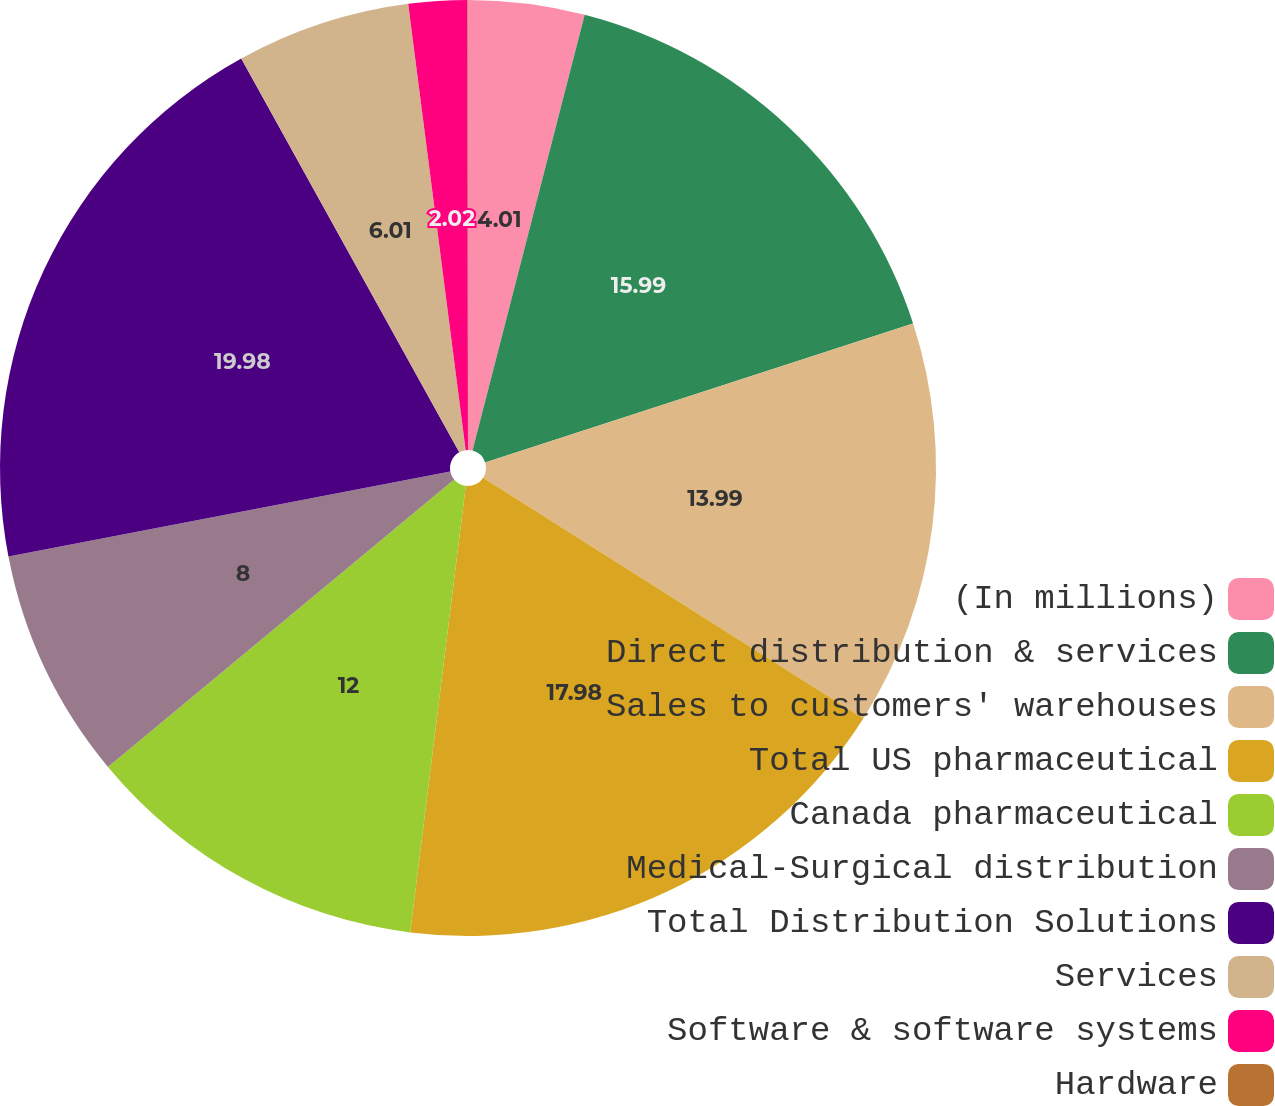<chart> <loc_0><loc_0><loc_500><loc_500><pie_chart><fcel>(In millions)<fcel>Direct distribution & services<fcel>Sales to customers' warehouses<fcel>Total US pharmaceutical<fcel>Canada pharmaceutical<fcel>Medical-Surgical distribution<fcel>Total Distribution Solutions<fcel>Services<fcel>Software & software systems<fcel>Hardware<nl><fcel>4.01%<fcel>15.99%<fcel>13.99%<fcel>17.98%<fcel>12.0%<fcel>8.0%<fcel>19.98%<fcel>6.01%<fcel>2.02%<fcel>0.02%<nl></chart> 